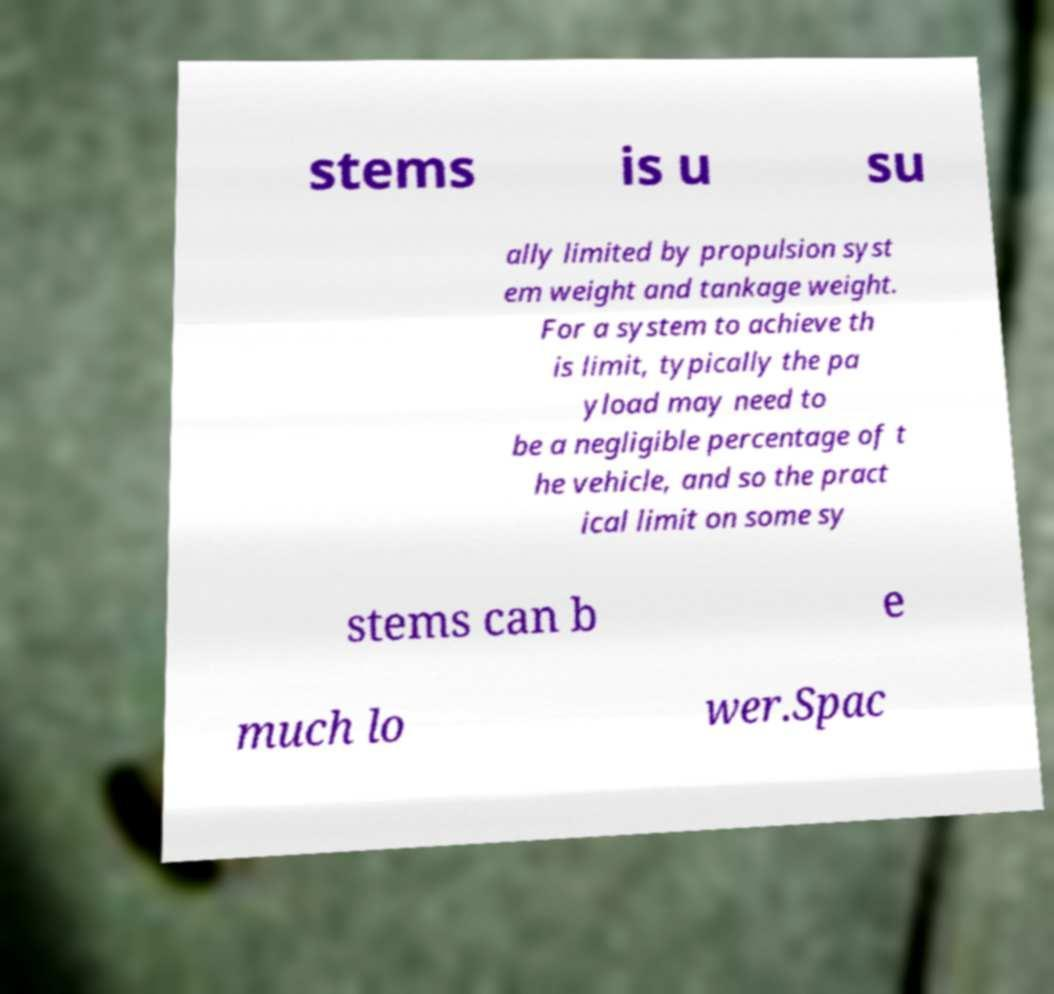I need the written content from this picture converted into text. Can you do that? stems is u su ally limited by propulsion syst em weight and tankage weight. For a system to achieve th is limit, typically the pa yload may need to be a negligible percentage of t he vehicle, and so the pract ical limit on some sy stems can b e much lo wer.Spac 